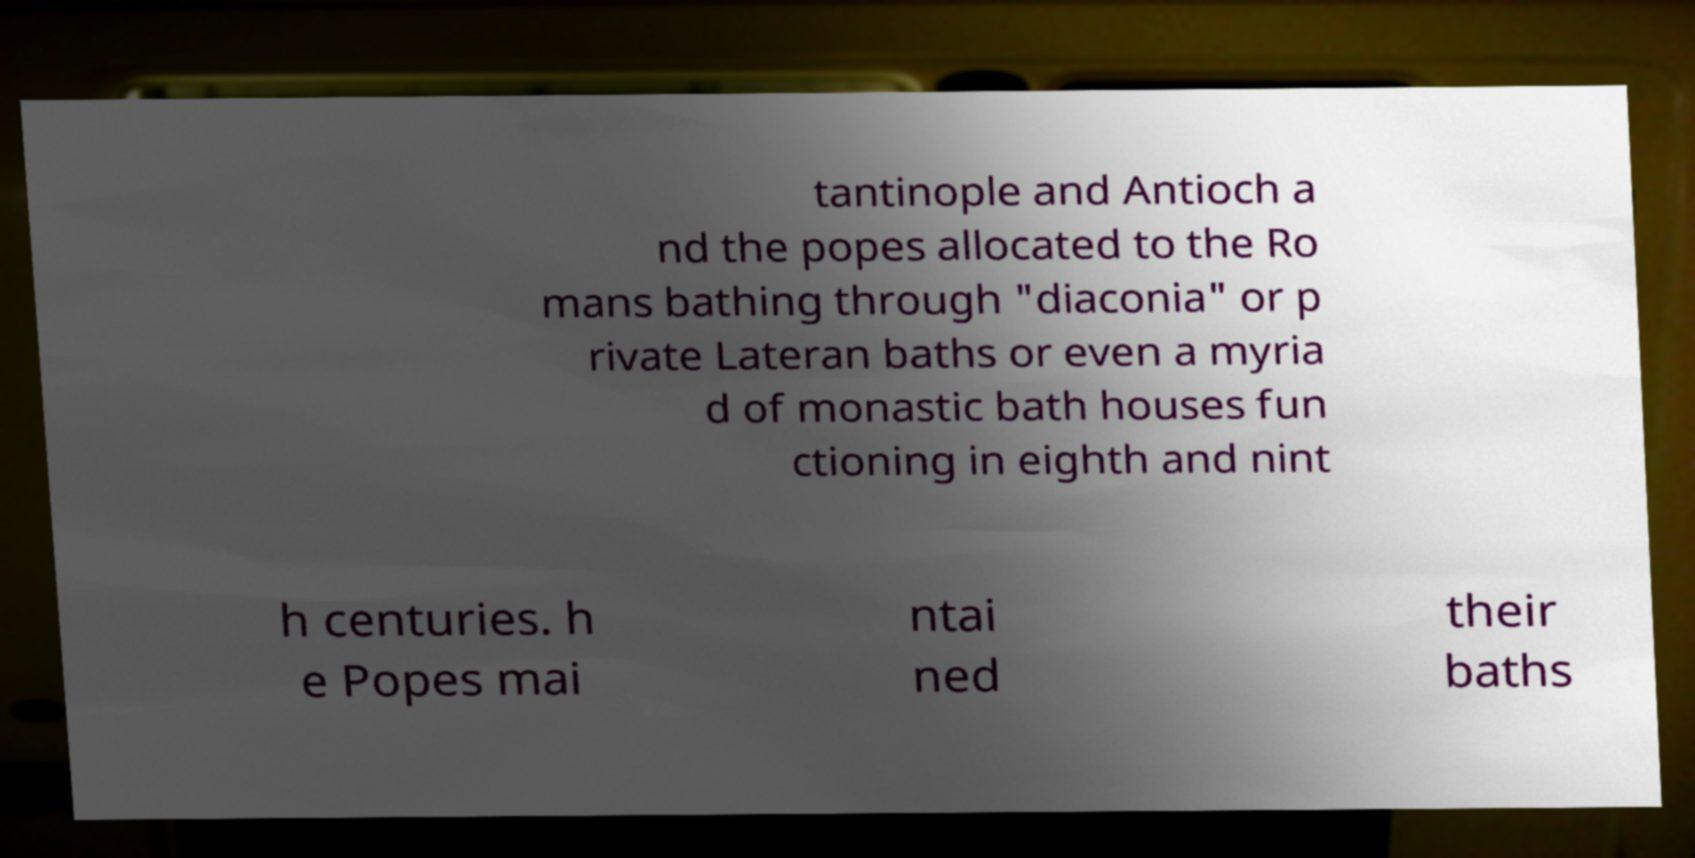I need the written content from this picture converted into text. Can you do that? tantinople and Antioch a nd the popes allocated to the Ro mans bathing through "diaconia" or p rivate Lateran baths or even a myria d of monastic bath houses fun ctioning in eighth and nint h centuries. h e Popes mai ntai ned their baths 